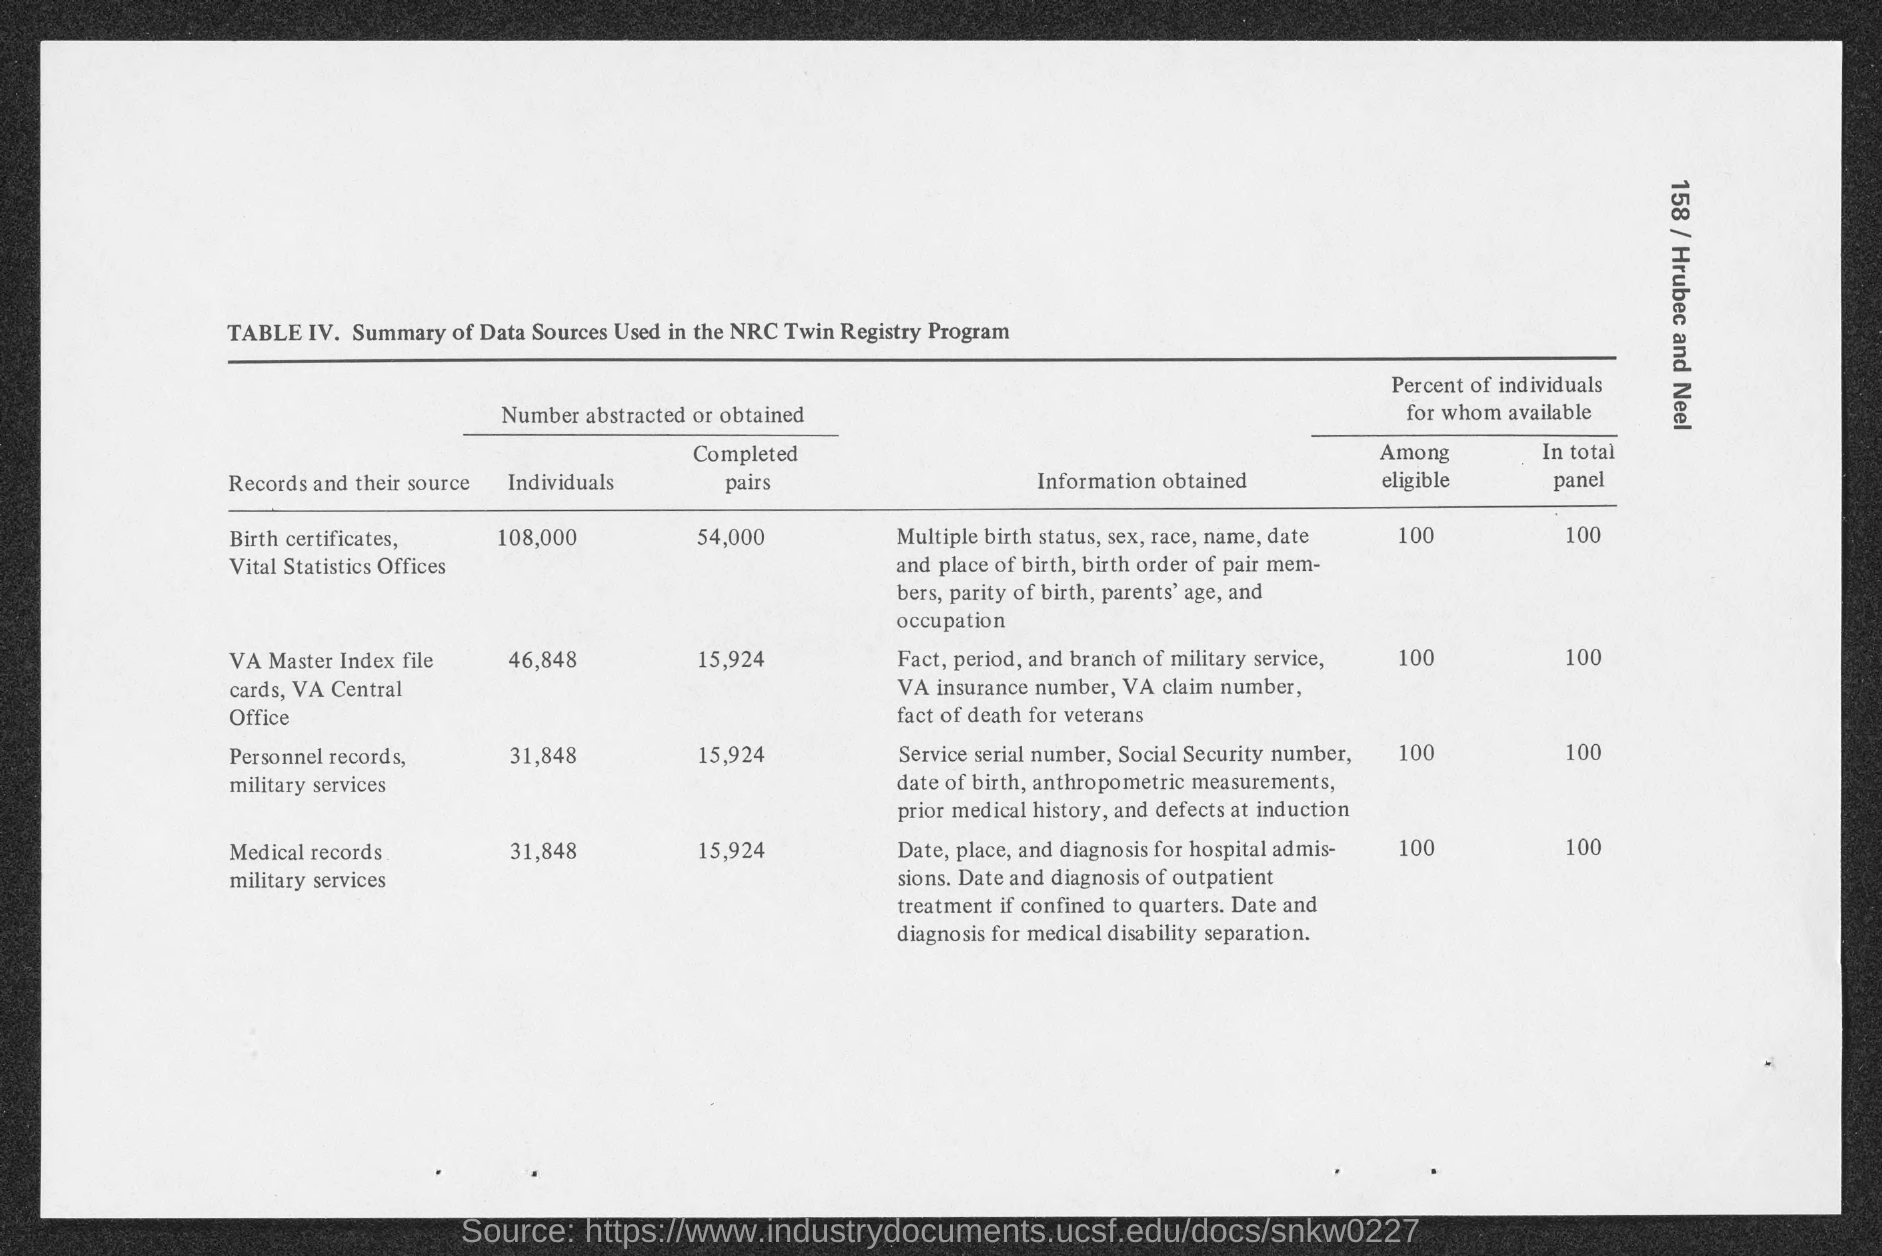Outline some significant characteristics in this image. The records that had the highest number of completed pairs were birth certificates and Vital Statistics Offices. The title of table IV is "Summary of Data Sources Used in the NRC Twin Registry Program. The study obtained information on 31,848 individuals from military medical records. 